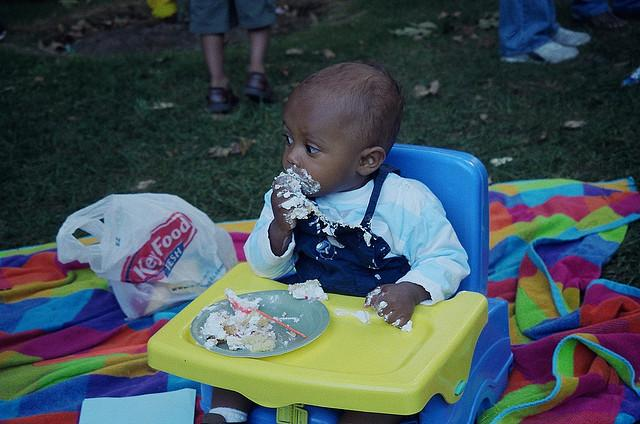Why is this person so messy? baby 